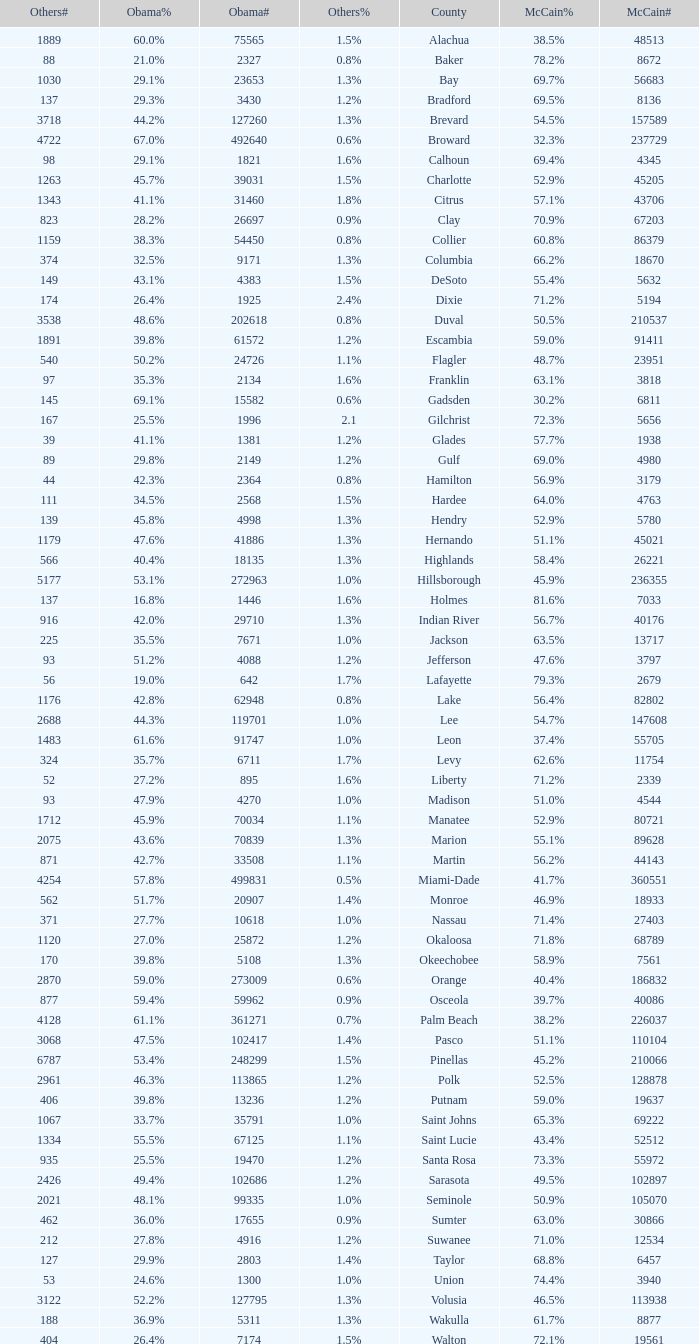What percentage was the others vote when McCain had 52.9% and less than 45205.0 voters? 1.3%. 